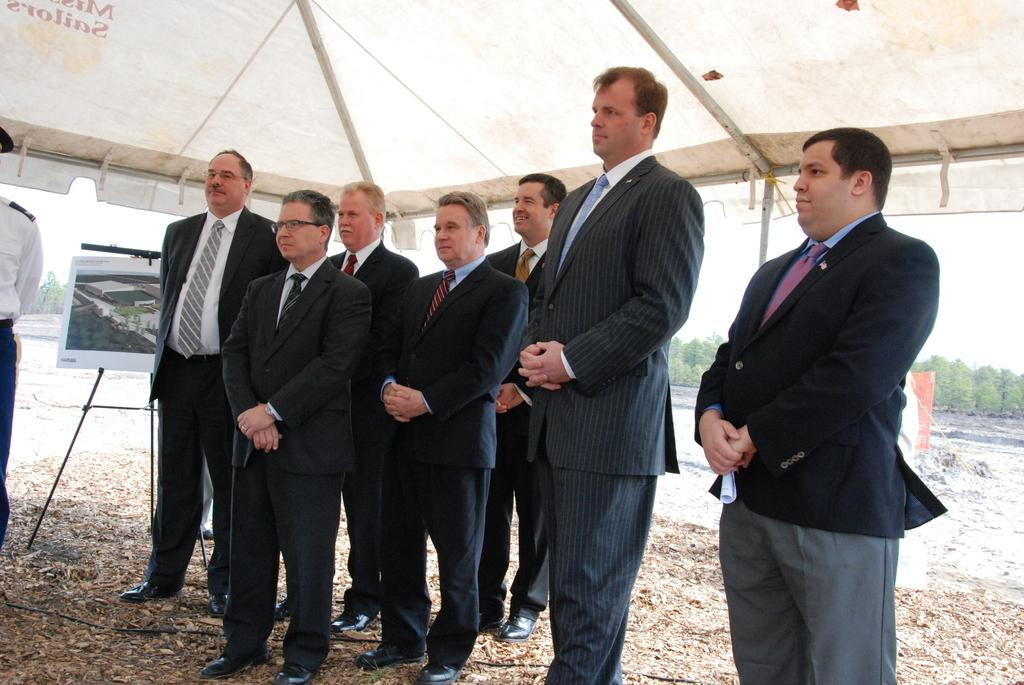How many people are in the image? There is a group of people in the image, but the exact number is not specified. Where are the people located in the image? The people are standing under a tent in the image. What object can be seen on a stand in the image? There is a picture frame on a stand in the image. What type of natural elements are visible in the image? There are leaves and trees visible in the image. What is the wire on the ground used for? The purpose of the wire on the ground is not specified in the facts. What type of furniture is being used to hold the jelly in the image? There is no furniture or jelly present in the image. How many tubs are visible in the image? There are no tubs visible in the image. 